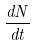<formula> <loc_0><loc_0><loc_500><loc_500>\frac { d N } { d t }</formula> 